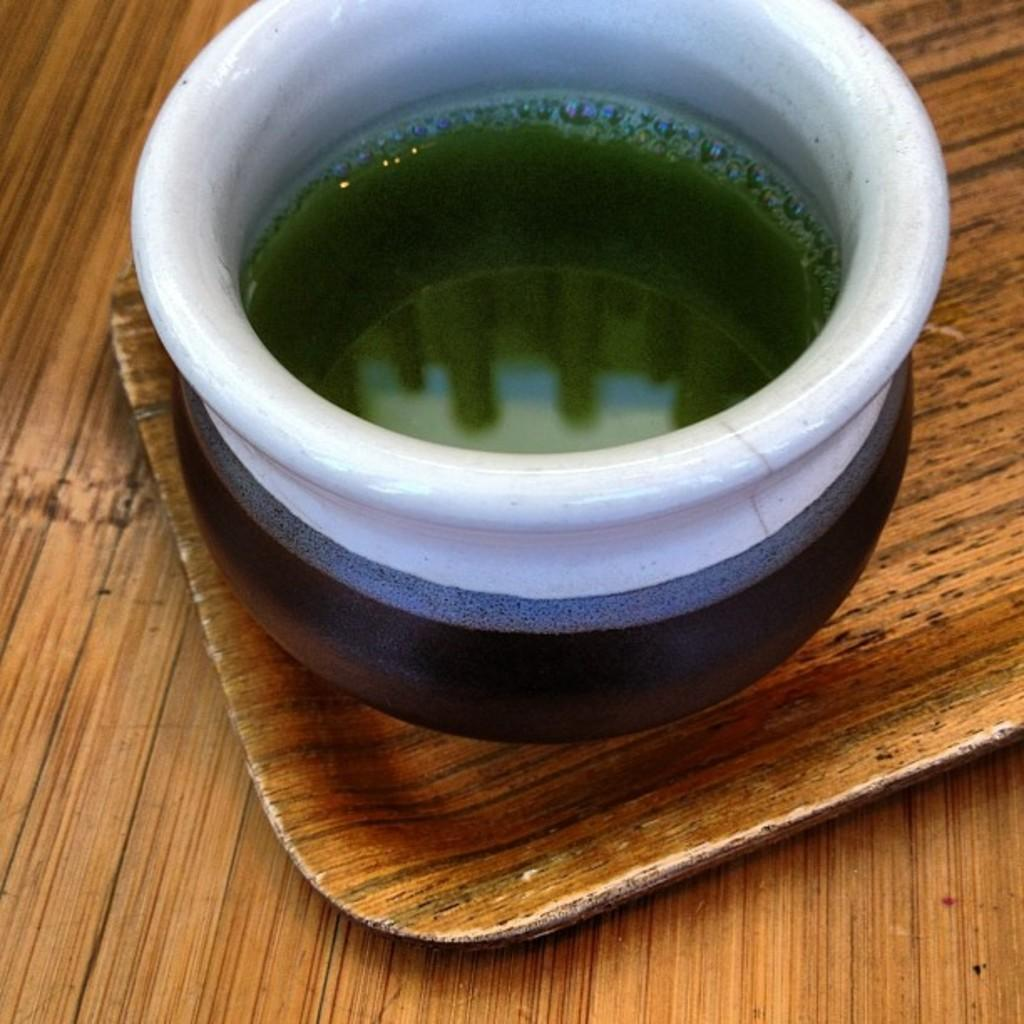What is in the pot that is visible in the image? There is a pot with liquid in the image. What can be observed in the liquid? There are bubbles in the liquid. Where is the pot placed in the image? The pot is on a wooden tray. What type of surface is visible in the image? There is a wooden surface visible in the image. How does the clam react to the liquid in the image? There is no clam present in the image. 